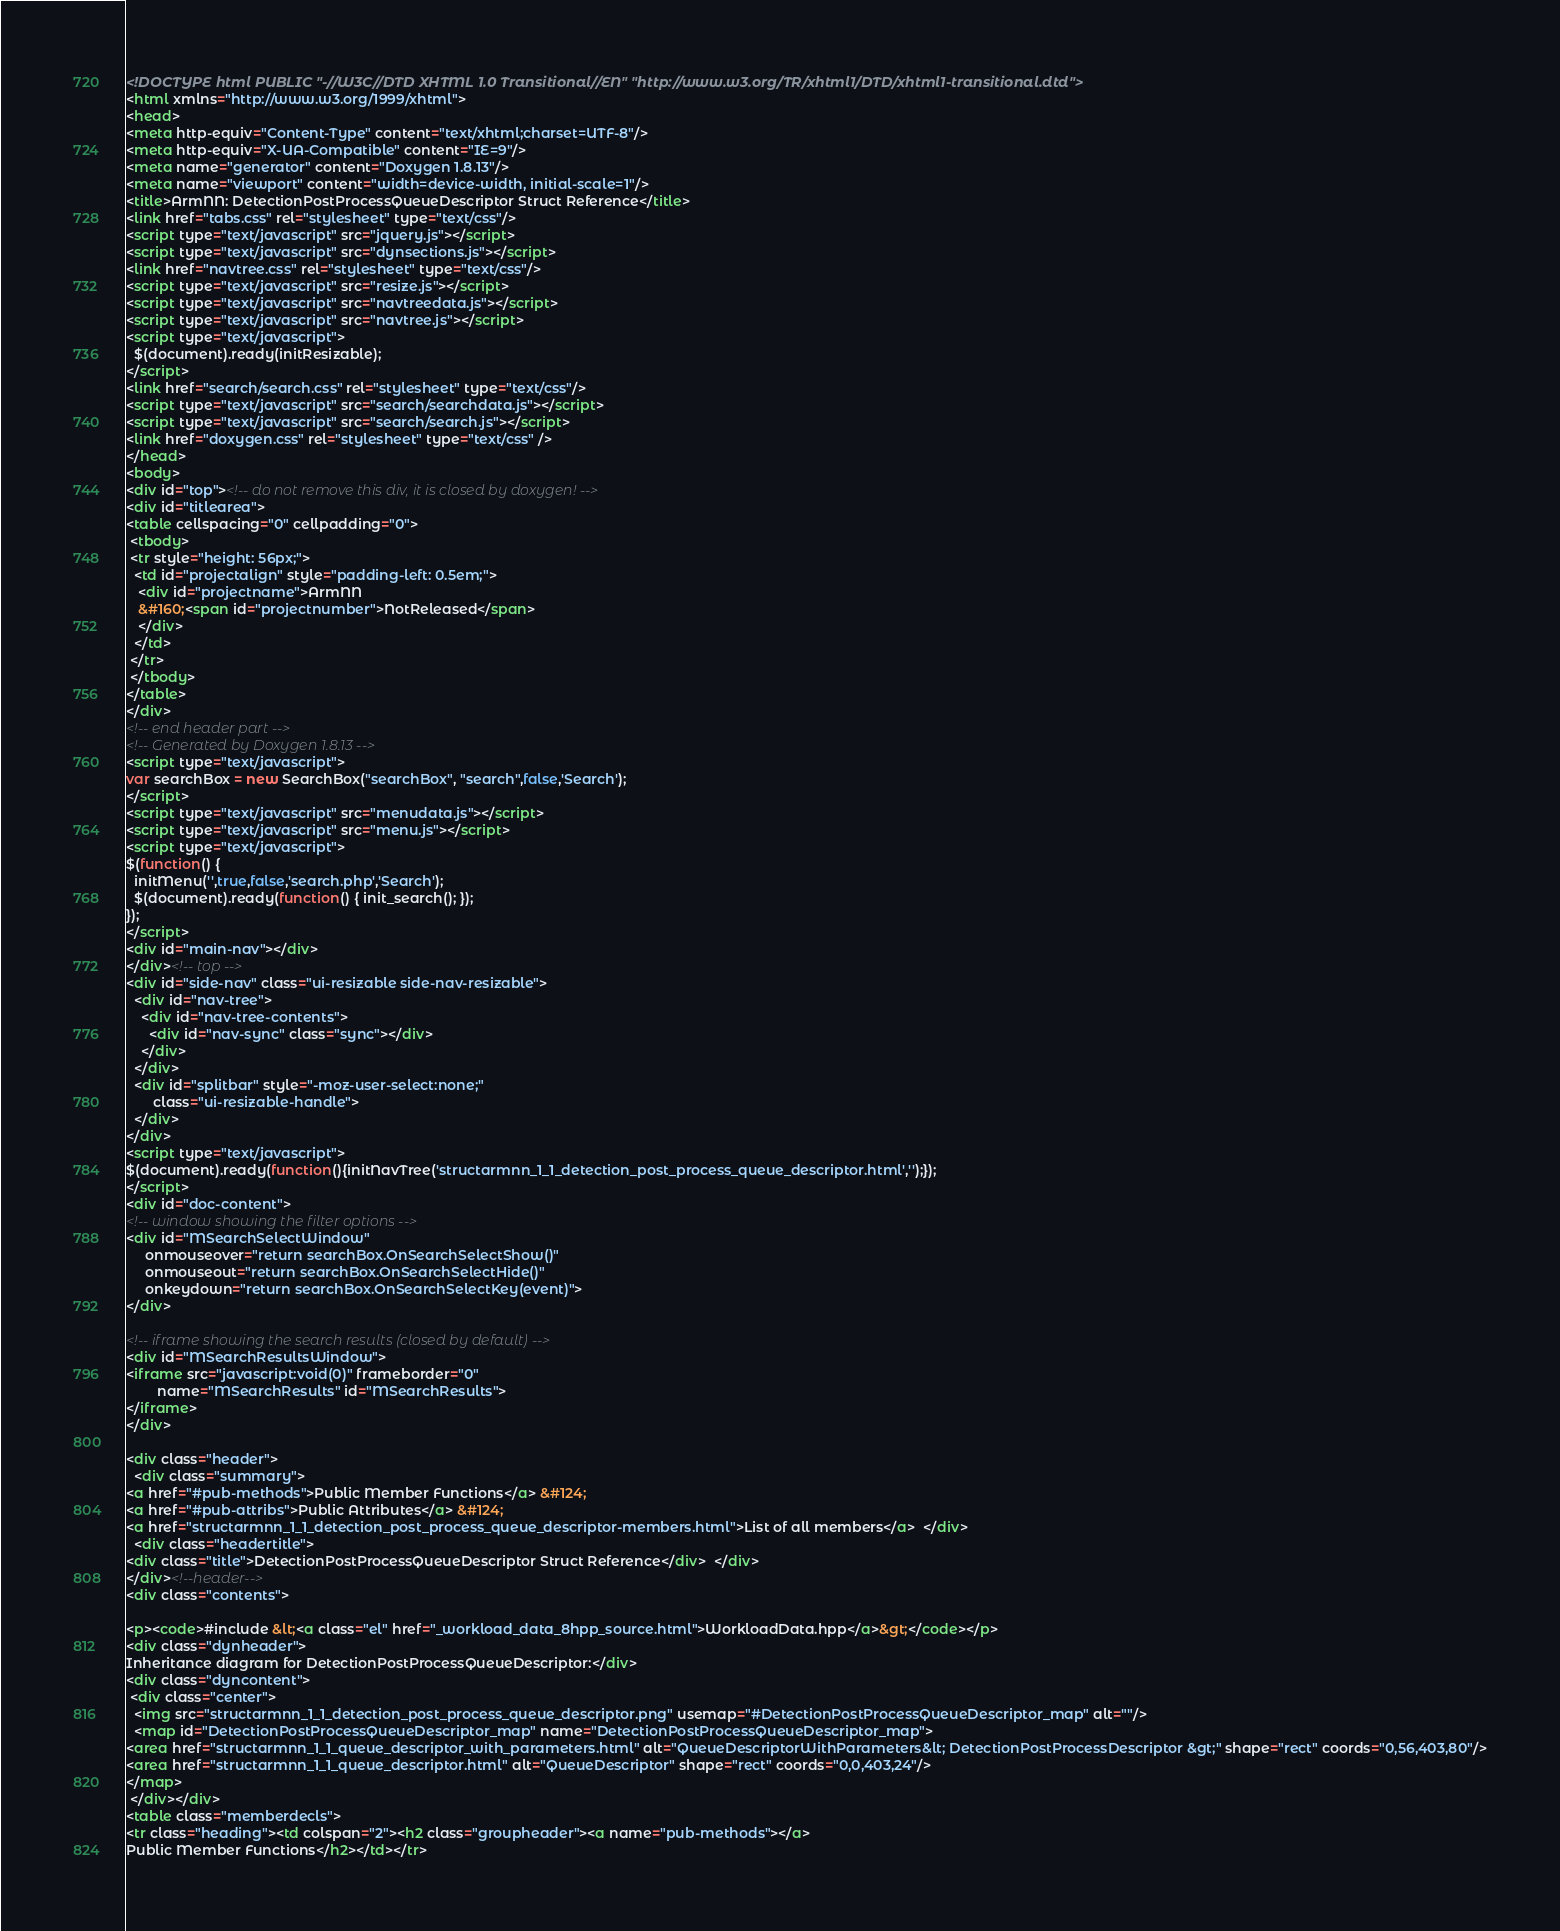<code> <loc_0><loc_0><loc_500><loc_500><_HTML_><!DOCTYPE html PUBLIC "-//W3C//DTD XHTML 1.0 Transitional//EN" "http://www.w3.org/TR/xhtml1/DTD/xhtml1-transitional.dtd">
<html xmlns="http://www.w3.org/1999/xhtml">
<head>
<meta http-equiv="Content-Type" content="text/xhtml;charset=UTF-8"/>
<meta http-equiv="X-UA-Compatible" content="IE=9"/>
<meta name="generator" content="Doxygen 1.8.13"/>
<meta name="viewport" content="width=device-width, initial-scale=1"/>
<title>ArmNN: DetectionPostProcessQueueDescriptor Struct Reference</title>
<link href="tabs.css" rel="stylesheet" type="text/css"/>
<script type="text/javascript" src="jquery.js"></script>
<script type="text/javascript" src="dynsections.js"></script>
<link href="navtree.css" rel="stylesheet" type="text/css"/>
<script type="text/javascript" src="resize.js"></script>
<script type="text/javascript" src="navtreedata.js"></script>
<script type="text/javascript" src="navtree.js"></script>
<script type="text/javascript">
  $(document).ready(initResizable);
</script>
<link href="search/search.css" rel="stylesheet" type="text/css"/>
<script type="text/javascript" src="search/searchdata.js"></script>
<script type="text/javascript" src="search/search.js"></script>
<link href="doxygen.css" rel="stylesheet" type="text/css" />
</head>
<body>
<div id="top"><!-- do not remove this div, it is closed by doxygen! -->
<div id="titlearea">
<table cellspacing="0" cellpadding="0">
 <tbody>
 <tr style="height: 56px;">
  <td id="projectalign" style="padding-left: 0.5em;">
   <div id="projectname">ArmNN
   &#160;<span id="projectnumber">NotReleased</span>
   </div>
  </td>
 </tr>
 </tbody>
</table>
</div>
<!-- end header part -->
<!-- Generated by Doxygen 1.8.13 -->
<script type="text/javascript">
var searchBox = new SearchBox("searchBox", "search",false,'Search');
</script>
<script type="text/javascript" src="menudata.js"></script>
<script type="text/javascript" src="menu.js"></script>
<script type="text/javascript">
$(function() {
  initMenu('',true,false,'search.php','Search');
  $(document).ready(function() { init_search(); });
});
</script>
<div id="main-nav"></div>
</div><!-- top -->
<div id="side-nav" class="ui-resizable side-nav-resizable">
  <div id="nav-tree">
    <div id="nav-tree-contents">
      <div id="nav-sync" class="sync"></div>
    </div>
  </div>
  <div id="splitbar" style="-moz-user-select:none;" 
       class="ui-resizable-handle">
  </div>
</div>
<script type="text/javascript">
$(document).ready(function(){initNavTree('structarmnn_1_1_detection_post_process_queue_descriptor.html','');});
</script>
<div id="doc-content">
<!-- window showing the filter options -->
<div id="MSearchSelectWindow"
     onmouseover="return searchBox.OnSearchSelectShow()"
     onmouseout="return searchBox.OnSearchSelectHide()"
     onkeydown="return searchBox.OnSearchSelectKey(event)">
</div>

<!-- iframe showing the search results (closed by default) -->
<div id="MSearchResultsWindow">
<iframe src="javascript:void(0)" frameborder="0" 
        name="MSearchResults" id="MSearchResults">
</iframe>
</div>

<div class="header">
  <div class="summary">
<a href="#pub-methods">Public Member Functions</a> &#124;
<a href="#pub-attribs">Public Attributes</a> &#124;
<a href="structarmnn_1_1_detection_post_process_queue_descriptor-members.html">List of all members</a>  </div>
  <div class="headertitle">
<div class="title">DetectionPostProcessQueueDescriptor Struct Reference</div>  </div>
</div><!--header-->
<div class="contents">

<p><code>#include &lt;<a class="el" href="_workload_data_8hpp_source.html">WorkloadData.hpp</a>&gt;</code></p>
<div class="dynheader">
Inheritance diagram for DetectionPostProcessQueueDescriptor:</div>
<div class="dyncontent">
 <div class="center">
  <img src="structarmnn_1_1_detection_post_process_queue_descriptor.png" usemap="#DetectionPostProcessQueueDescriptor_map" alt=""/>
  <map id="DetectionPostProcessQueueDescriptor_map" name="DetectionPostProcessQueueDescriptor_map">
<area href="structarmnn_1_1_queue_descriptor_with_parameters.html" alt="QueueDescriptorWithParameters&lt; DetectionPostProcessDescriptor &gt;" shape="rect" coords="0,56,403,80"/>
<area href="structarmnn_1_1_queue_descriptor.html" alt="QueueDescriptor" shape="rect" coords="0,0,403,24"/>
</map>
 </div></div>
<table class="memberdecls">
<tr class="heading"><td colspan="2"><h2 class="groupheader"><a name="pub-methods"></a>
Public Member Functions</h2></td></tr></code> 